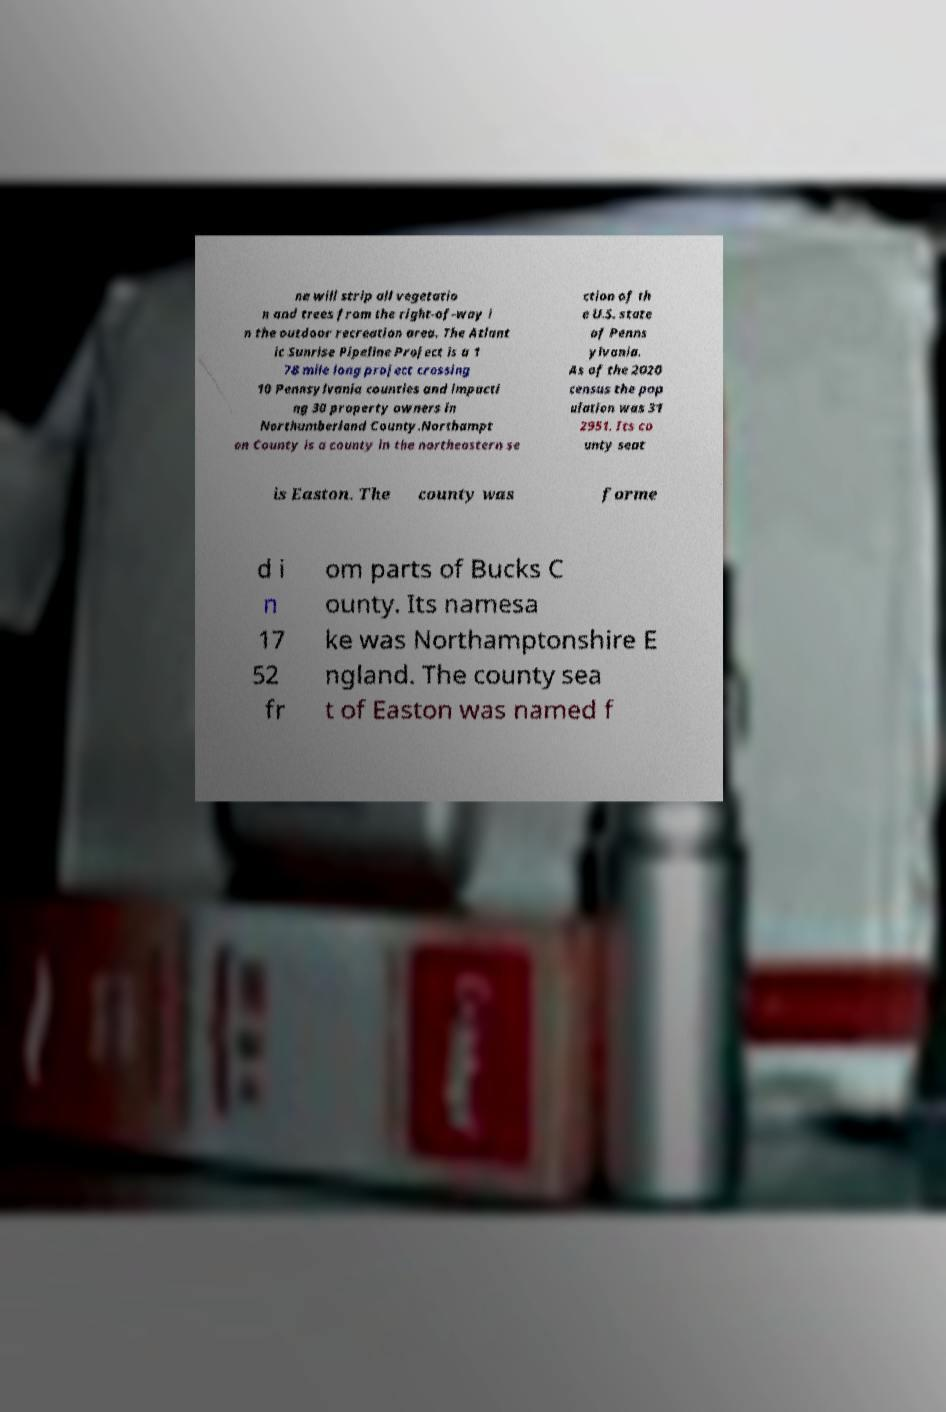Please read and relay the text visible in this image. What does it say? ne will strip all vegetatio n and trees from the right-of-way i n the outdoor recreation area. The Atlant ic Sunrise Pipeline Project is a 1 78 mile long project crossing 10 Pennsylvania counties and impacti ng 30 property owners in Northumberland County.Northampt on County is a county in the northeastern se ction of th e U.S. state of Penns ylvania. As of the 2020 census the pop ulation was 31 2951. Its co unty seat is Easton. The county was forme d i n 17 52 fr om parts of Bucks C ounty. Its namesa ke was Northamptonshire E ngland. The county sea t of Easton was named f 